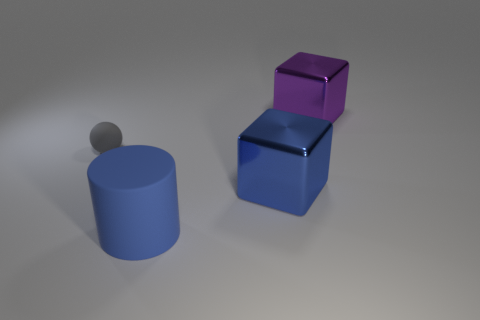Is the big cylinder made of the same material as the large cube behind the sphere?
Keep it short and to the point. No. What number of other big blue things have the same shape as the blue shiny object?
Your answer should be very brief. 0. What is the material of the big thing that is the same color as the big matte cylinder?
Make the answer very short. Metal. What number of purple cubes are there?
Your answer should be very brief. 1. Does the tiny object have the same shape as the blue object that is to the right of the large rubber cylinder?
Make the answer very short. No. How many objects are either gray rubber objects or matte objects that are on the left side of the big cylinder?
Provide a short and direct response. 1. There is another big object that is the same shape as the blue shiny thing; what is it made of?
Your response must be concise. Metal. Do the rubber object that is in front of the large blue metallic cube and the purple object have the same shape?
Your answer should be compact. No. Are there any other things that are the same size as the gray rubber object?
Give a very brief answer. No. Are there fewer large matte things that are on the right side of the blue matte object than large objects behind the small gray matte thing?
Ensure brevity in your answer.  Yes. 